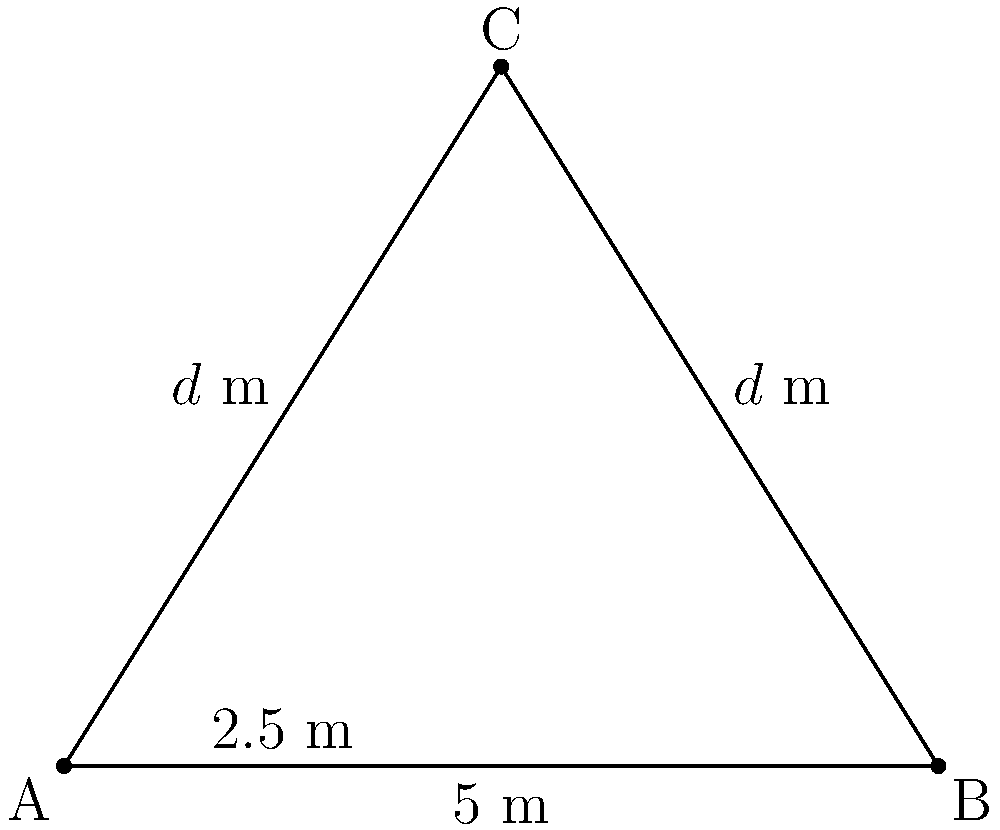A man walking in a park notices a couple at point C. He wants to maintain an optimal distance from them to avoid any nauseating displays of affection. If the width of the park's path is 5 meters, and the man wants to stay equidistant from both ends of the path (A and B) while maximizing his distance from the couple, what is the optimal distance $d$ (in meters) he should maintain? Let's approach this step-by-step:

1) The situation forms an isosceles triangle, with AC = BC = $d$ meters.

2) The base of the triangle (AB) is 5 meters.

3) The man's position (C) forms the apex of the isosceles triangle.

4) The height of the triangle bisects the base, creating two right triangles.

5) In one of these right triangles:
   - The base is 2.5 meters (half of AB)
   - The hypotenuse is $d$ meters

6) We can use the Pythagorean theorem:
   $d^2 = 2.5^2 + h^2$, where $h$ is the height of the triangle

7) The height $h$ is also the distance from the couple that we want to maximize.

8) To find the maximum value of $h$, we need to differentiate the equation with respect to $d$ and set it to zero:

   $d^2 = 2.5^2 + h^2$
   $h^2 = d^2 - 2.5^2$
   $h = \sqrt{d^2 - 2.5^2}$

9) Differentiating $h$ with respect to $d$:
   $\frac{dh}{dd} = \frac{d}{\sqrt{d^2 - 2.5^2}}$

10) Setting this to zero:
    $\frac{d}{\sqrt{d^2 - 2.5^2}} = 0$

11) This is only true when $d$ approaches infinity, which is not practical. The next best thing is to choose the largest reasonable value for $d$.

12) The largest possible value for $d$ is the hypotenuse of the right triangle formed by half the path width and the entire path width:

    $d^2 = 2.5^2 + 5^2 = 6.25 + 25 = 31.25$

13) Therefore, $d = \sqrt{31.25} = 5.59$ meters (rounded to two decimal places)
Answer: 5.59 meters 